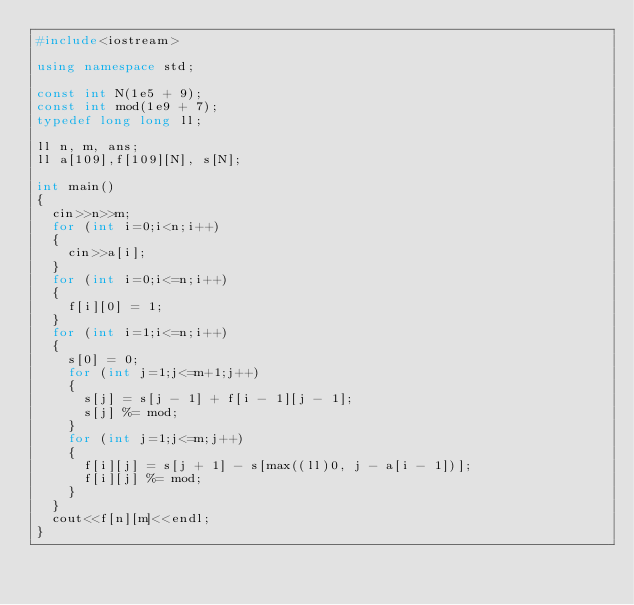<code> <loc_0><loc_0><loc_500><loc_500><_C++_>#include<iostream>

using namespace std;

const int N(1e5 + 9);
const int mod(1e9 + 7);
typedef long long ll;

ll n, m, ans;
ll a[109],f[109][N], s[N];

int main()
{
	cin>>n>>m;
	for (int i=0;i<n;i++)
	{
		cin>>a[i];
	}
	for (int i=0;i<=n;i++)
	{
		f[i][0] = 1;
	}
	for (int i=1;i<=n;i++)
	{
		s[0] = 0;
		for (int j=1;j<=m+1;j++)
		{
			s[j] = s[j - 1] + f[i - 1][j - 1];
			s[j] %= mod;
		}
		for (int j=1;j<=m;j++)
		{
			f[i][j] = s[j + 1] - s[max((ll)0, j - a[i - 1])];
			f[i][j] %= mod;
		}
	}
	cout<<f[n][m]<<endl;
}</code> 